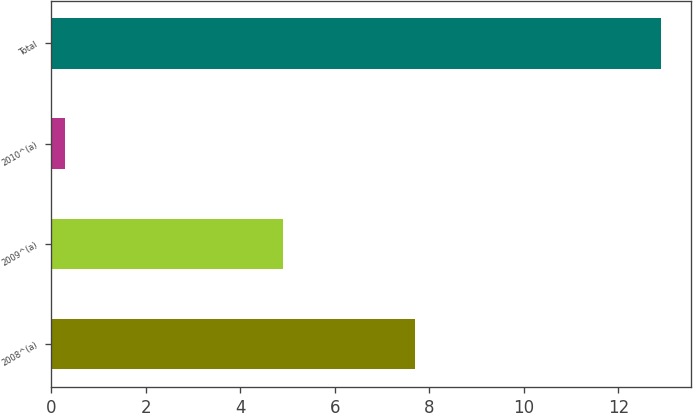Convert chart. <chart><loc_0><loc_0><loc_500><loc_500><bar_chart><fcel>2008^(a)<fcel>2009^(a)<fcel>2010^(a)<fcel>Total<nl><fcel>7.7<fcel>4.9<fcel>0.3<fcel>12.9<nl></chart> 